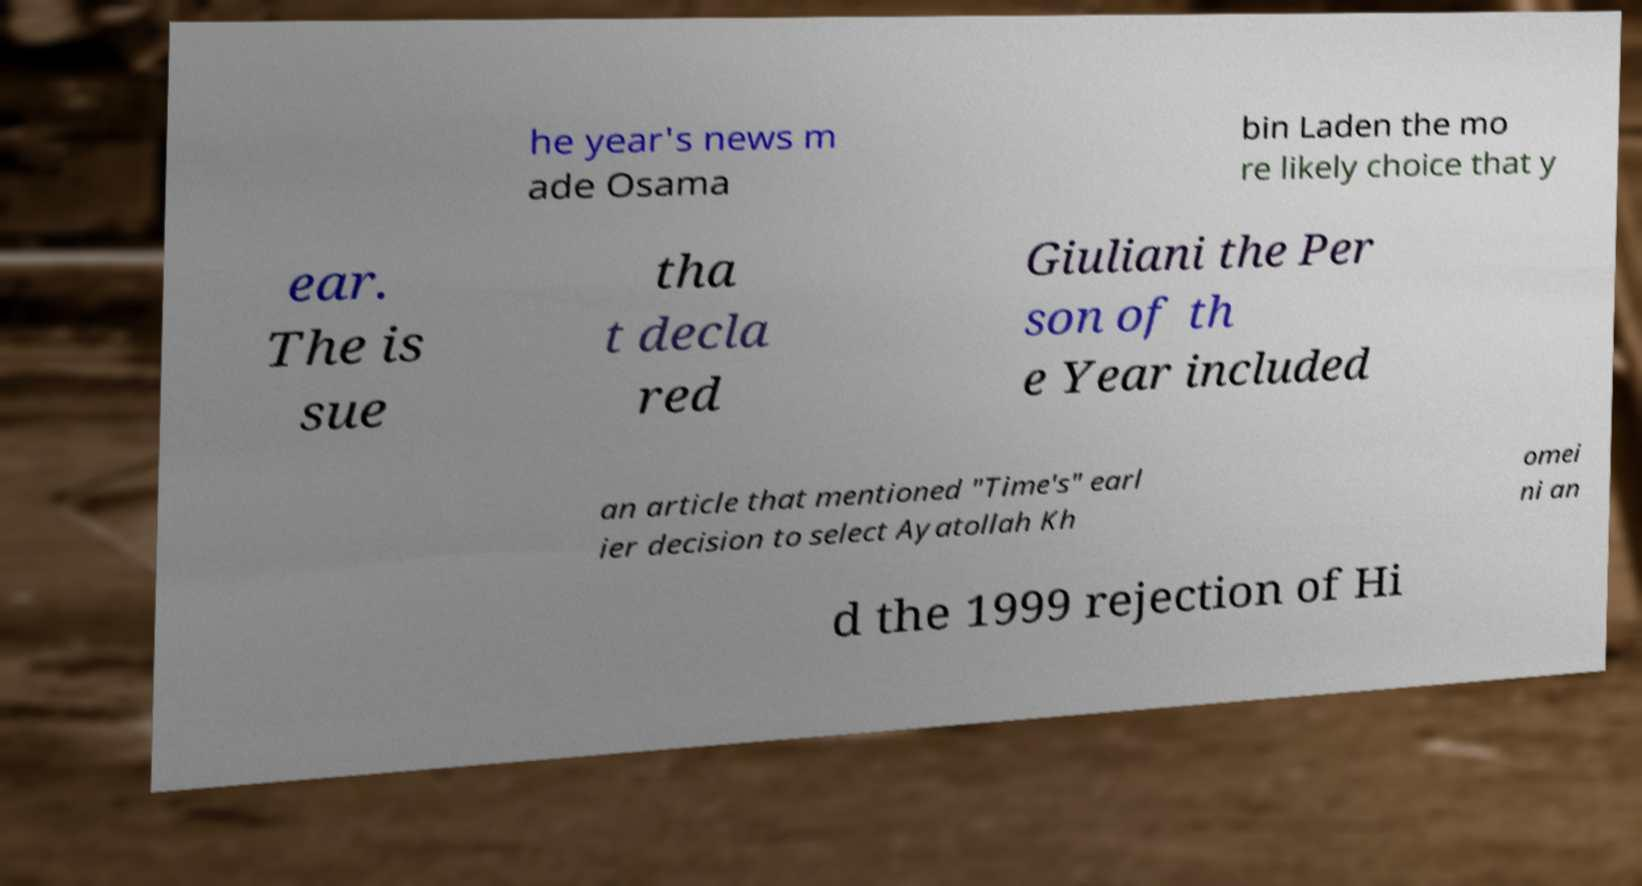For documentation purposes, I need the text within this image transcribed. Could you provide that? he year's news m ade Osama bin Laden the mo re likely choice that y ear. The is sue tha t decla red Giuliani the Per son of th e Year included an article that mentioned "Time's" earl ier decision to select Ayatollah Kh omei ni an d the 1999 rejection of Hi 